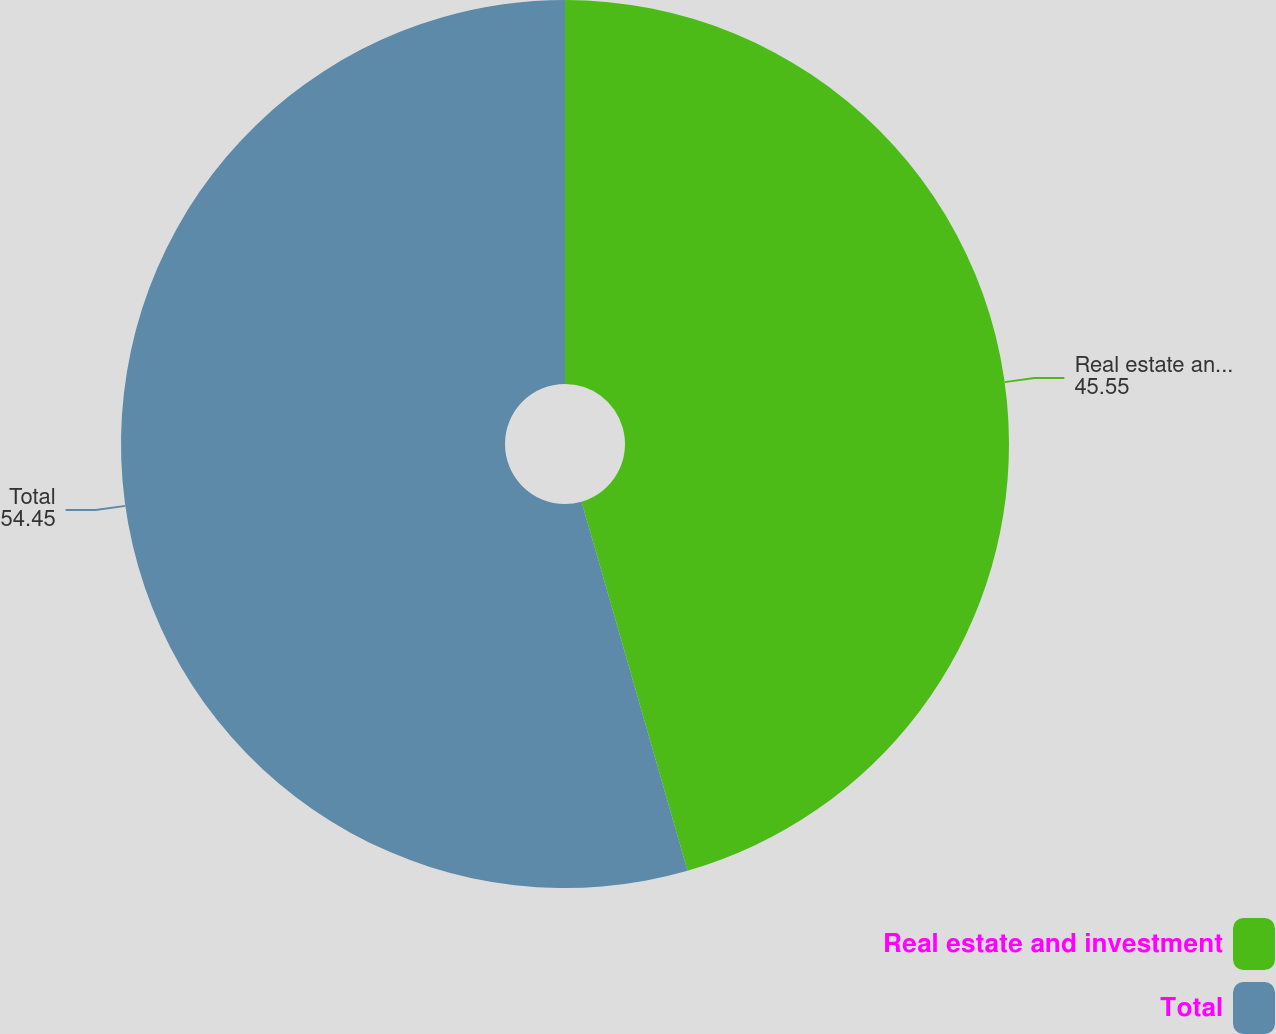Convert chart to OTSL. <chart><loc_0><loc_0><loc_500><loc_500><pie_chart><fcel>Real estate and investment<fcel>Total<nl><fcel>45.55%<fcel>54.45%<nl></chart> 